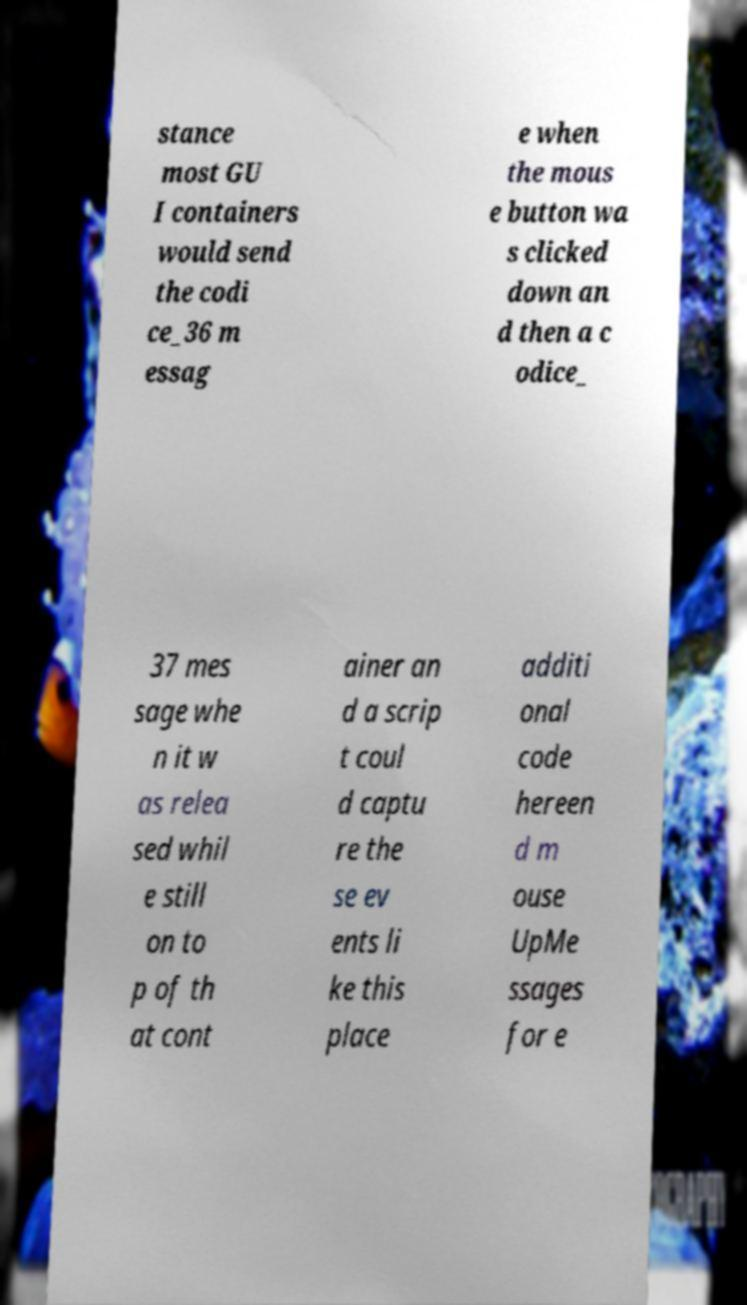Can you read and provide the text displayed in the image?This photo seems to have some interesting text. Can you extract and type it out for me? stance most GU I containers would send the codi ce_36 m essag e when the mous e button wa s clicked down an d then a c odice_ 37 mes sage whe n it w as relea sed whil e still on to p of th at cont ainer an d a scrip t coul d captu re the se ev ents li ke this place additi onal code hereen d m ouse UpMe ssages for e 